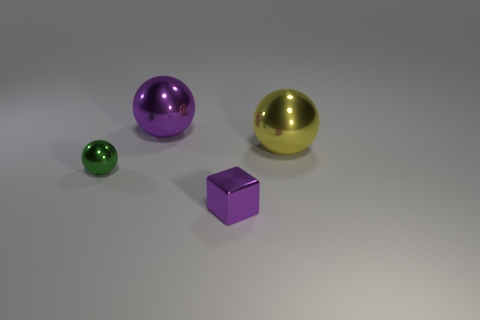What materials do these objects look like they're made of? The objects in the image have a reflective surface that suggests they are made of materials with a metallic or polished finish. Specifically, the larger orbs could be made of materials resembling polished metal such as brass or anodized aluminum, while the cube's matte finish suggests a plastic or painted metal surface.  Could you guess the time of day based on the lighting in this image? The lighting in the image appears artificial and doesn't provide any clues about the time of day. It seems like a controlled environment with a single light source casting soft shadows, which could be replicated at any time indoors. 